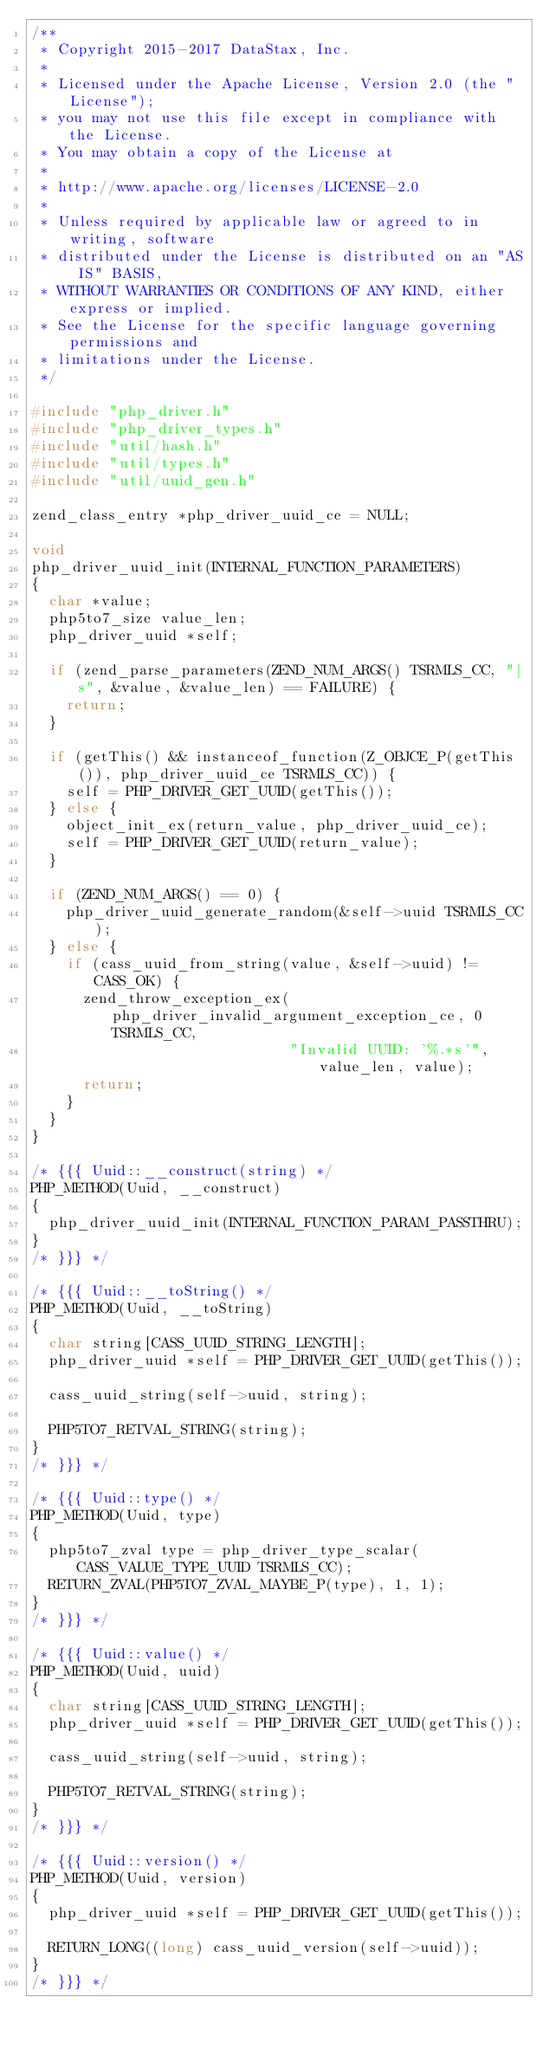<code> <loc_0><loc_0><loc_500><loc_500><_C_>/**
 * Copyright 2015-2017 DataStax, Inc.
 *
 * Licensed under the Apache License, Version 2.0 (the "License");
 * you may not use this file except in compliance with the License.
 * You may obtain a copy of the License at
 *
 * http://www.apache.org/licenses/LICENSE-2.0
 *
 * Unless required by applicable law or agreed to in writing, software
 * distributed under the License is distributed on an "AS IS" BASIS,
 * WITHOUT WARRANTIES OR CONDITIONS OF ANY KIND, either express or implied.
 * See the License for the specific language governing permissions and
 * limitations under the License.
 */

#include "php_driver.h"
#include "php_driver_types.h"
#include "util/hash.h"
#include "util/types.h"
#include "util/uuid_gen.h"

zend_class_entry *php_driver_uuid_ce = NULL;

void
php_driver_uuid_init(INTERNAL_FUNCTION_PARAMETERS)
{
  char *value;
  php5to7_size value_len;
  php_driver_uuid *self;

  if (zend_parse_parameters(ZEND_NUM_ARGS() TSRMLS_CC, "|s", &value, &value_len) == FAILURE) {
    return;
  }

  if (getThis() && instanceof_function(Z_OBJCE_P(getThis()), php_driver_uuid_ce TSRMLS_CC)) {
    self = PHP_DRIVER_GET_UUID(getThis());
  } else {
    object_init_ex(return_value, php_driver_uuid_ce);
    self = PHP_DRIVER_GET_UUID(return_value);
  }

  if (ZEND_NUM_ARGS() == 0) {
    php_driver_uuid_generate_random(&self->uuid TSRMLS_CC);
  } else {
    if (cass_uuid_from_string(value, &self->uuid) != CASS_OK) {
      zend_throw_exception_ex(php_driver_invalid_argument_exception_ce, 0 TSRMLS_CC,
                              "Invalid UUID: '%.*s'", value_len, value);
      return;
    }
  }
}

/* {{{ Uuid::__construct(string) */
PHP_METHOD(Uuid, __construct)
{
  php_driver_uuid_init(INTERNAL_FUNCTION_PARAM_PASSTHRU);
}
/* }}} */

/* {{{ Uuid::__toString() */
PHP_METHOD(Uuid, __toString)
{
  char string[CASS_UUID_STRING_LENGTH];
  php_driver_uuid *self = PHP_DRIVER_GET_UUID(getThis());

  cass_uuid_string(self->uuid, string);

  PHP5TO7_RETVAL_STRING(string);
}
/* }}} */

/* {{{ Uuid::type() */
PHP_METHOD(Uuid, type)
{
  php5to7_zval type = php_driver_type_scalar(CASS_VALUE_TYPE_UUID TSRMLS_CC);
  RETURN_ZVAL(PHP5TO7_ZVAL_MAYBE_P(type), 1, 1);
}
/* }}} */

/* {{{ Uuid::value() */
PHP_METHOD(Uuid, uuid)
{
  char string[CASS_UUID_STRING_LENGTH];
  php_driver_uuid *self = PHP_DRIVER_GET_UUID(getThis());

  cass_uuid_string(self->uuid, string);

  PHP5TO7_RETVAL_STRING(string);
}
/* }}} */

/* {{{ Uuid::version() */
PHP_METHOD(Uuid, version)
{
  php_driver_uuid *self = PHP_DRIVER_GET_UUID(getThis());

  RETURN_LONG((long) cass_uuid_version(self->uuid));
}
/* }}} */
</code> 